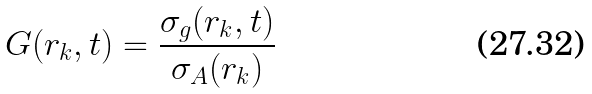<formula> <loc_0><loc_0><loc_500><loc_500>G ( r _ { k } , t ) = \frac { \sigma _ { g } ( r _ { k } , t ) } { \sigma _ { A } ( r _ { k } ) }</formula> 